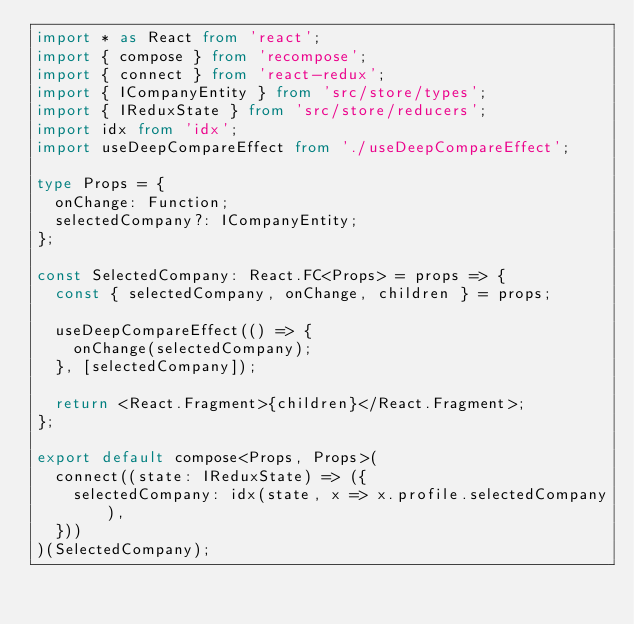<code> <loc_0><loc_0><loc_500><loc_500><_TypeScript_>import * as React from 'react';
import { compose } from 'recompose';
import { connect } from 'react-redux';
import { ICompanyEntity } from 'src/store/types';
import { IReduxState } from 'src/store/reducers';
import idx from 'idx';
import useDeepCompareEffect from './useDeepCompareEffect';

type Props = {
  onChange: Function;
  selectedCompany?: ICompanyEntity;
};

const SelectedCompany: React.FC<Props> = props => {
  const { selectedCompany, onChange, children } = props;

  useDeepCompareEffect(() => {
    onChange(selectedCompany);
  }, [selectedCompany]);

  return <React.Fragment>{children}</React.Fragment>;
};

export default compose<Props, Props>(
  connect((state: IReduxState) => ({
    selectedCompany: idx(state, x => x.profile.selectedCompany),
  }))
)(SelectedCompany);
</code> 